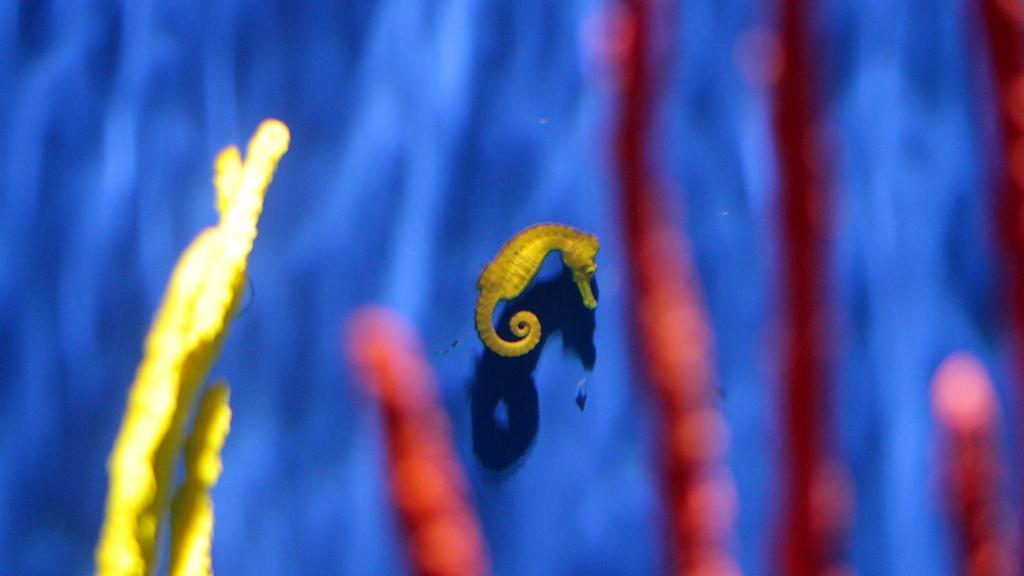Describe this image in one or two sentences. In this picture there is the sea horse in the middle and there is some undefined object present nearby. 